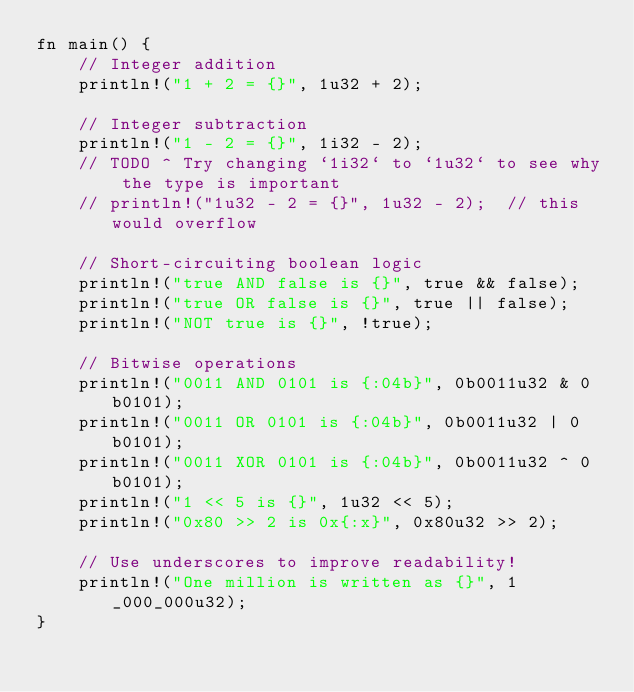Convert code to text. <code><loc_0><loc_0><loc_500><loc_500><_Rust_>fn main() {
    // Integer addition
    println!("1 + 2 = {}", 1u32 + 2);

    // Integer subtraction
    println!("1 - 2 = {}", 1i32 - 2);
    // TODO ^ Try changing `1i32` to `1u32` to see why the type is important
    // println!("1u32 - 2 = {}", 1u32 - 2);  // this would overflow

    // Short-circuiting boolean logic
    println!("true AND false is {}", true && false);
    println!("true OR false is {}", true || false);
    println!("NOT true is {}", !true);

    // Bitwise operations
    println!("0011 AND 0101 is {:04b}", 0b0011u32 & 0b0101);
    println!("0011 OR 0101 is {:04b}", 0b0011u32 | 0b0101);
    println!("0011 XOR 0101 is {:04b}", 0b0011u32 ^ 0b0101);
    println!("1 << 5 is {}", 1u32 << 5);
    println!("0x80 >> 2 is 0x{:x}", 0x80u32 >> 2);

    // Use underscores to improve readability!
    println!("One million is written as {}", 1_000_000u32);
}
</code> 